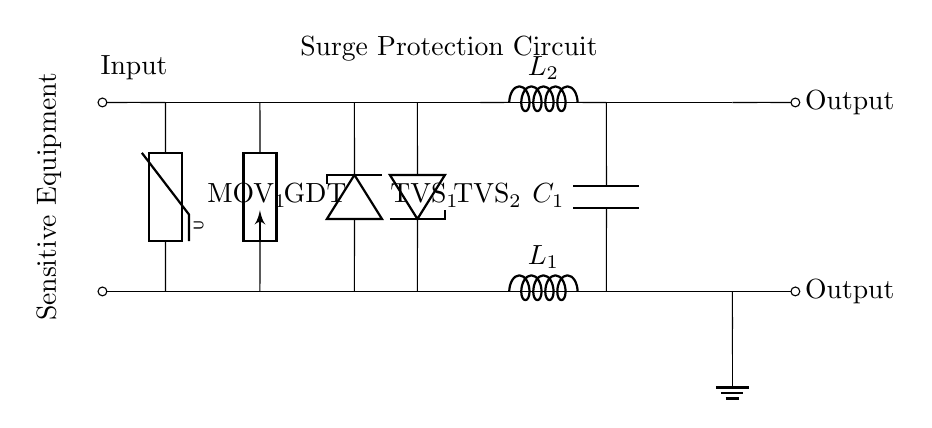What type of surge protection component is used first in the circuit? The first surge protection component in the circuit is a Metal Oxide Varistor, indicated as MOV1. This component is positioned at the beginning of the surge protection path, immediately after the input.
Answer: Metal Oxide Varistor What does GDT stand for in the circuit diagram? GDT stands for Gas Discharge Tube, which is a type of surge protection device used to divert excess voltage. It is located between the MOV and the TVS diodes in the circuit.
Answer: Gas Discharge Tube How many TVS diodes are present in the circuit? There are two TVS diodes indicated as TVS1 and TVS2 in the circuit diagram, positioned in parallel to the surge path to clamp excessive voltages.
Answer: Two What is the purpose of the inductors in this circuit? The inductors, labeled as L1 and L2, serve to limit the rate of change of current and filter out high-frequency noise that could damage sensitive equipment. Their placement ensures that surges do not reach the load directly.
Answer: Limit current change Which component provides filtering along with the surge protection? The capacitor labeled C1 at the end of the surge protection circuit is responsible for filtering out remaining high-frequency noise and stabilizing the voltage for sensitive electronic equipment, ensuring better performance under surge conditions.
Answer: Capacitor What connection type is used between the output terminals and the rest of the circuit? The output terminals are connected using short connections labeled with "o," indicating an open connection to the load, which allows power to flow to the sensitive equipment protected by the surge protection circuit.
Answer: Short connection 